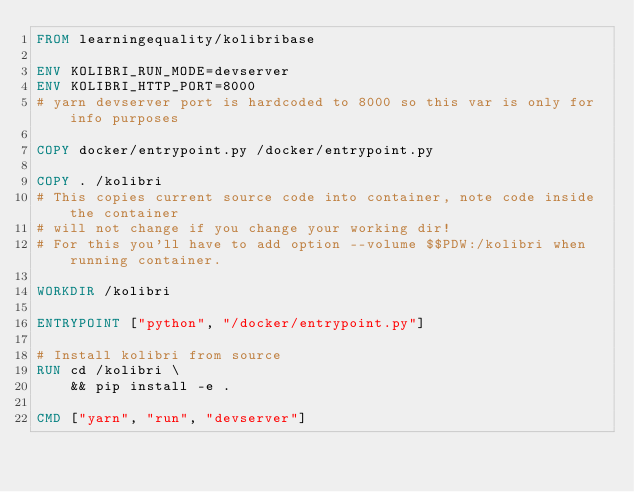Convert code to text. <code><loc_0><loc_0><loc_500><loc_500><_Dockerfile_>FROM learningequality/kolibribase

ENV KOLIBRI_RUN_MODE=devserver
ENV KOLIBRI_HTTP_PORT=8000
# yarn devserver port is hardcoded to 8000 so this var is only for info purposes

COPY docker/entrypoint.py /docker/entrypoint.py

COPY . /kolibri
# This copies current source code into container, note code inside the container
# will not change if you change your working dir!
# For this you'll have to add option --volume $$PDW:/kolibri when running container.

WORKDIR /kolibri

ENTRYPOINT ["python", "/docker/entrypoint.py"]

# Install kolibri from source
RUN cd /kolibri \
    && pip install -e .

CMD ["yarn", "run", "devserver"]
</code> 